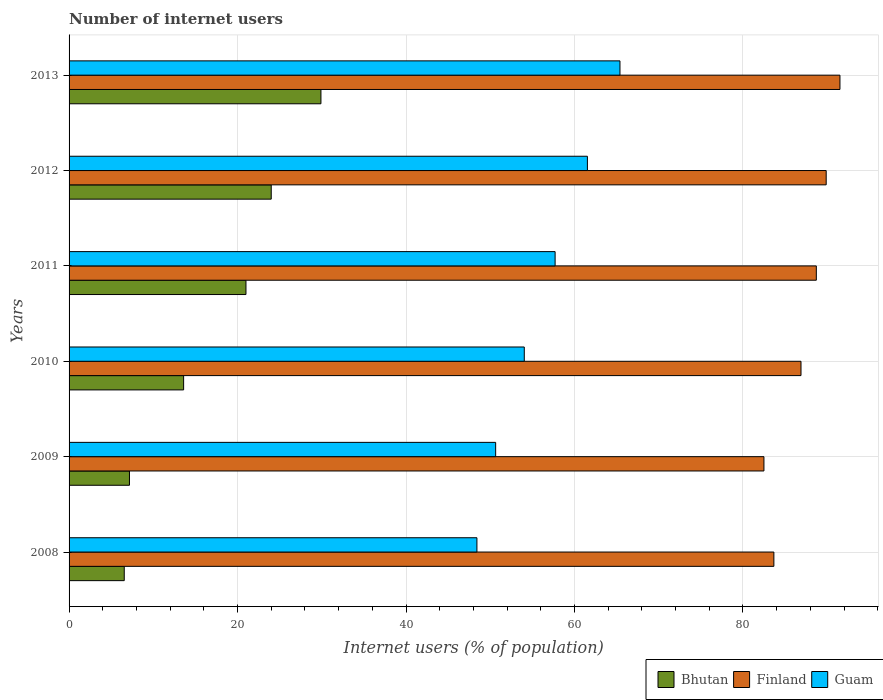How many different coloured bars are there?
Provide a short and direct response. 3. How many bars are there on the 2nd tick from the top?
Keep it short and to the point. 3. How many bars are there on the 3rd tick from the bottom?
Keep it short and to the point. 3. What is the label of the 6th group of bars from the top?
Keep it short and to the point. 2008. What is the number of internet users in Finland in 2008?
Give a very brief answer. 83.67. Across all years, what is the maximum number of internet users in Guam?
Your answer should be compact. 65.4. Across all years, what is the minimum number of internet users in Bhutan?
Provide a short and direct response. 6.55. In which year was the number of internet users in Finland maximum?
Keep it short and to the point. 2013. What is the total number of internet users in Finland in the graph?
Keep it short and to the point. 523.15. What is the difference between the number of internet users in Finland in 2011 and that in 2013?
Make the answer very short. -2.8. What is the difference between the number of internet users in Guam in 2010 and the number of internet users in Finland in 2009?
Give a very brief answer. -28.45. What is the average number of internet users in Bhutan per year?
Keep it short and to the point. 17.04. In the year 2013, what is the difference between the number of internet users in Finland and number of internet users in Bhutan?
Ensure brevity in your answer.  61.61. In how many years, is the number of internet users in Bhutan greater than 88 %?
Offer a very short reply. 0. What is the ratio of the number of internet users in Bhutan in 2008 to that in 2009?
Give a very brief answer. 0.91. Is the number of internet users in Finland in 2012 less than that in 2013?
Provide a succinct answer. Yes. What is the difference between the highest and the second highest number of internet users in Guam?
Make the answer very short. 3.87. What is the difference between the highest and the lowest number of internet users in Finland?
Your answer should be very brief. 9.02. What does the 1st bar from the top in 2013 represents?
Your answer should be very brief. Guam. What does the 1st bar from the bottom in 2008 represents?
Your response must be concise. Bhutan. Is it the case that in every year, the sum of the number of internet users in Bhutan and number of internet users in Guam is greater than the number of internet users in Finland?
Your answer should be very brief. No. How many bars are there?
Offer a terse response. 18. How many years are there in the graph?
Keep it short and to the point. 6. Are the values on the major ticks of X-axis written in scientific E-notation?
Keep it short and to the point. No. Does the graph contain any zero values?
Offer a very short reply. No. Does the graph contain grids?
Ensure brevity in your answer.  Yes. Where does the legend appear in the graph?
Your answer should be compact. Bottom right. How many legend labels are there?
Ensure brevity in your answer.  3. What is the title of the graph?
Ensure brevity in your answer.  Number of internet users. What is the label or title of the X-axis?
Ensure brevity in your answer.  Internet users (% of population). What is the Internet users (% of population) of Bhutan in 2008?
Make the answer very short. 6.55. What is the Internet users (% of population) in Finland in 2008?
Your answer should be compact. 83.67. What is the Internet users (% of population) of Guam in 2008?
Provide a short and direct response. 48.42. What is the Internet users (% of population) of Bhutan in 2009?
Give a very brief answer. 7.17. What is the Internet users (% of population) in Finland in 2009?
Offer a terse response. 82.49. What is the Internet users (% of population) of Guam in 2009?
Ensure brevity in your answer.  50.64. What is the Internet users (% of population) in Finland in 2010?
Your answer should be very brief. 86.89. What is the Internet users (% of population) in Guam in 2010?
Offer a terse response. 54.04. What is the Internet users (% of population) of Finland in 2011?
Offer a very short reply. 88.71. What is the Internet users (% of population) of Guam in 2011?
Offer a very short reply. 57.7. What is the Internet users (% of population) of Finland in 2012?
Make the answer very short. 89.88. What is the Internet users (% of population) of Guam in 2012?
Offer a very short reply. 61.53. What is the Internet users (% of population) of Bhutan in 2013?
Your answer should be very brief. 29.9. What is the Internet users (% of population) in Finland in 2013?
Make the answer very short. 91.51. What is the Internet users (% of population) of Guam in 2013?
Give a very brief answer. 65.4. Across all years, what is the maximum Internet users (% of population) of Bhutan?
Your response must be concise. 29.9. Across all years, what is the maximum Internet users (% of population) in Finland?
Give a very brief answer. 91.51. Across all years, what is the maximum Internet users (% of population) of Guam?
Offer a very short reply. 65.4. Across all years, what is the minimum Internet users (% of population) in Bhutan?
Offer a very short reply. 6.55. Across all years, what is the minimum Internet users (% of population) in Finland?
Offer a terse response. 82.49. Across all years, what is the minimum Internet users (% of population) of Guam?
Your answer should be very brief. 48.42. What is the total Internet users (% of population) in Bhutan in the graph?
Keep it short and to the point. 102.22. What is the total Internet users (% of population) of Finland in the graph?
Ensure brevity in your answer.  523.15. What is the total Internet users (% of population) in Guam in the graph?
Offer a terse response. 337.73. What is the difference between the Internet users (% of population) of Bhutan in 2008 and that in 2009?
Ensure brevity in your answer.  -0.62. What is the difference between the Internet users (% of population) in Finland in 2008 and that in 2009?
Offer a very short reply. 1.18. What is the difference between the Internet users (% of population) of Guam in 2008 and that in 2009?
Offer a very short reply. -2.22. What is the difference between the Internet users (% of population) in Bhutan in 2008 and that in 2010?
Make the answer very short. -7.05. What is the difference between the Internet users (% of population) in Finland in 2008 and that in 2010?
Ensure brevity in your answer.  -3.22. What is the difference between the Internet users (% of population) of Guam in 2008 and that in 2010?
Ensure brevity in your answer.  -5.62. What is the difference between the Internet users (% of population) of Bhutan in 2008 and that in 2011?
Offer a terse response. -14.45. What is the difference between the Internet users (% of population) of Finland in 2008 and that in 2011?
Make the answer very short. -5.04. What is the difference between the Internet users (% of population) in Guam in 2008 and that in 2011?
Offer a terse response. -9.28. What is the difference between the Internet users (% of population) in Bhutan in 2008 and that in 2012?
Give a very brief answer. -17.45. What is the difference between the Internet users (% of population) of Finland in 2008 and that in 2012?
Offer a very short reply. -6.21. What is the difference between the Internet users (% of population) of Guam in 2008 and that in 2012?
Ensure brevity in your answer.  -13.12. What is the difference between the Internet users (% of population) in Bhutan in 2008 and that in 2013?
Keep it short and to the point. -23.35. What is the difference between the Internet users (% of population) of Finland in 2008 and that in 2013?
Offer a very short reply. -7.84. What is the difference between the Internet users (% of population) in Guam in 2008 and that in 2013?
Your answer should be very brief. -16.98. What is the difference between the Internet users (% of population) in Bhutan in 2009 and that in 2010?
Provide a succinct answer. -6.43. What is the difference between the Internet users (% of population) in Finland in 2009 and that in 2010?
Your answer should be compact. -4.4. What is the difference between the Internet users (% of population) of Guam in 2009 and that in 2010?
Offer a very short reply. -3.4. What is the difference between the Internet users (% of population) of Bhutan in 2009 and that in 2011?
Offer a terse response. -13.83. What is the difference between the Internet users (% of population) of Finland in 2009 and that in 2011?
Make the answer very short. -6.22. What is the difference between the Internet users (% of population) of Guam in 2009 and that in 2011?
Provide a short and direct response. -7.06. What is the difference between the Internet users (% of population) in Bhutan in 2009 and that in 2012?
Make the answer very short. -16.83. What is the difference between the Internet users (% of population) of Finland in 2009 and that in 2012?
Provide a succinct answer. -7.39. What is the difference between the Internet users (% of population) in Guam in 2009 and that in 2012?
Your answer should be very brief. -10.89. What is the difference between the Internet users (% of population) of Bhutan in 2009 and that in 2013?
Offer a very short reply. -22.73. What is the difference between the Internet users (% of population) in Finland in 2009 and that in 2013?
Your answer should be compact. -9.02. What is the difference between the Internet users (% of population) in Guam in 2009 and that in 2013?
Provide a succinct answer. -14.76. What is the difference between the Internet users (% of population) in Finland in 2010 and that in 2011?
Provide a succinct answer. -1.82. What is the difference between the Internet users (% of population) of Guam in 2010 and that in 2011?
Keep it short and to the point. -3.66. What is the difference between the Internet users (% of population) of Finland in 2010 and that in 2012?
Make the answer very short. -2.99. What is the difference between the Internet users (% of population) of Guam in 2010 and that in 2012?
Give a very brief answer. -7.49. What is the difference between the Internet users (% of population) in Bhutan in 2010 and that in 2013?
Give a very brief answer. -16.3. What is the difference between the Internet users (% of population) in Finland in 2010 and that in 2013?
Make the answer very short. -4.62. What is the difference between the Internet users (% of population) of Guam in 2010 and that in 2013?
Make the answer very short. -11.36. What is the difference between the Internet users (% of population) of Bhutan in 2011 and that in 2012?
Give a very brief answer. -3. What is the difference between the Internet users (% of population) in Finland in 2011 and that in 2012?
Ensure brevity in your answer.  -1.17. What is the difference between the Internet users (% of population) in Guam in 2011 and that in 2012?
Make the answer very short. -3.83. What is the difference between the Internet users (% of population) of Bhutan in 2011 and that in 2013?
Provide a short and direct response. -8.9. What is the difference between the Internet users (% of population) of Finland in 2011 and that in 2013?
Offer a very short reply. -2.8. What is the difference between the Internet users (% of population) in Guam in 2011 and that in 2013?
Your answer should be compact. -7.7. What is the difference between the Internet users (% of population) of Bhutan in 2012 and that in 2013?
Keep it short and to the point. -5.9. What is the difference between the Internet users (% of population) in Finland in 2012 and that in 2013?
Provide a short and direct response. -1.63. What is the difference between the Internet users (% of population) in Guam in 2012 and that in 2013?
Provide a succinct answer. -3.87. What is the difference between the Internet users (% of population) of Bhutan in 2008 and the Internet users (% of population) of Finland in 2009?
Ensure brevity in your answer.  -75.94. What is the difference between the Internet users (% of population) of Bhutan in 2008 and the Internet users (% of population) of Guam in 2009?
Your answer should be compact. -44.09. What is the difference between the Internet users (% of population) in Finland in 2008 and the Internet users (% of population) in Guam in 2009?
Keep it short and to the point. 33.03. What is the difference between the Internet users (% of population) in Bhutan in 2008 and the Internet users (% of population) in Finland in 2010?
Your answer should be compact. -80.34. What is the difference between the Internet users (% of population) in Bhutan in 2008 and the Internet users (% of population) in Guam in 2010?
Offer a terse response. -47.49. What is the difference between the Internet users (% of population) of Finland in 2008 and the Internet users (% of population) of Guam in 2010?
Make the answer very short. 29.63. What is the difference between the Internet users (% of population) of Bhutan in 2008 and the Internet users (% of population) of Finland in 2011?
Offer a terse response. -82.16. What is the difference between the Internet users (% of population) in Bhutan in 2008 and the Internet users (% of population) in Guam in 2011?
Your answer should be compact. -51.15. What is the difference between the Internet users (% of population) of Finland in 2008 and the Internet users (% of population) of Guam in 2011?
Make the answer very short. 25.97. What is the difference between the Internet users (% of population) in Bhutan in 2008 and the Internet users (% of population) in Finland in 2012?
Give a very brief answer. -83.33. What is the difference between the Internet users (% of population) in Bhutan in 2008 and the Internet users (% of population) in Guam in 2012?
Your response must be concise. -54.98. What is the difference between the Internet users (% of population) of Finland in 2008 and the Internet users (% of population) of Guam in 2012?
Your response must be concise. 22.14. What is the difference between the Internet users (% of population) in Bhutan in 2008 and the Internet users (% of population) in Finland in 2013?
Your answer should be compact. -84.96. What is the difference between the Internet users (% of population) in Bhutan in 2008 and the Internet users (% of population) in Guam in 2013?
Offer a terse response. -58.85. What is the difference between the Internet users (% of population) of Finland in 2008 and the Internet users (% of population) of Guam in 2013?
Provide a succinct answer. 18.27. What is the difference between the Internet users (% of population) of Bhutan in 2009 and the Internet users (% of population) of Finland in 2010?
Your answer should be very brief. -79.72. What is the difference between the Internet users (% of population) in Bhutan in 2009 and the Internet users (% of population) in Guam in 2010?
Make the answer very short. -46.87. What is the difference between the Internet users (% of population) of Finland in 2009 and the Internet users (% of population) of Guam in 2010?
Make the answer very short. 28.45. What is the difference between the Internet users (% of population) of Bhutan in 2009 and the Internet users (% of population) of Finland in 2011?
Give a very brief answer. -81.54. What is the difference between the Internet users (% of population) in Bhutan in 2009 and the Internet users (% of population) in Guam in 2011?
Keep it short and to the point. -50.53. What is the difference between the Internet users (% of population) in Finland in 2009 and the Internet users (% of population) in Guam in 2011?
Make the answer very short. 24.79. What is the difference between the Internet users (% of population) in Bhutan in 2009 and the Internet users (% of population) in Finland in 2012?
Provide a succinct answer. -82.71. What is the difference between the Internet users (% of population) in Bhutan in 2009 and the Internet users (% of population) in Guam in 2012?
Make the answer very short. -54.36. What is the difference between the Internet users (% of population) in Finland in 2009 and the Internet users (% of population) in Guam in 2012?
Offer a terse response. 20.96. What is the difference between the Internet users (% of population) of Bhutan in 2009 and the Internet users (% of population) of Finland in 2013?
Your answer should be very brief. -84.34. What is the difference between the Internet users (% of population) in Bhutan in 2009 and the Internet users (% of population) in Guam in 2013?
Keep it short and to the point. -58.23. What is the difference between the Internet users (% of population) in Finland in 2009 and the Internet users (% of population) in Guam in 2013?
Provide a short and direct response. 17.09. What is the difference between the Internet users (% of population) of Bhutan in 2010 and the Internet users (% of population) of Finland in 2011?
Provide a succinct answer. -75.11. What is the difference between the Internet users (% of population) of Bhutan in 2010 and the Internet users (% of population) of Guam in 2011?
Make the answer very short. -44.1. What is the difference between the Internet users (% of population) in Finland in 2010 and the Internet users (% of population) in Guam in 2011?
Your answer should be compact. 29.19. What is the difference between the Internet users (% of population) in Bhutan in 2010 and the Internet users (% of population) in Finland in 2012?
Provide a succinct answer. -76.28. What is the difference between the Internet users (% of population) in Bhutan in 2010 and the Internet users (% of population) in Guam in 2012?
Offer a very short reply. -47.93. What is the difference between the Internet users (% of population) in Finland in 2010 and the Internet users (% of population) in Guam in 2012?
Make the answer very short. 25.36. What is the difference between the Internet users (% of population) in Bhutan in 2010 and the Internet users (% of population) in Finland in 2013?
Keep it short and to the point. -77.91. What is the difference between the Internet users (% of population) of Bhutan in 2010 and the Internet users (% of population) of Guam in 2013?
Make the answer very short. -51.8. What is the difference between the Internet users (% of population) of Finland in 2010 and the Internet users (% of population) of Guam in 2013?
Offer a very short reply. 21.49. What is the difference between the Internet users (% of population) in Bhutan in 2011 and the Internet users (% of population) in Finland in 2012?
Your answer should be very brief. -68.88. What is the difference between the Internet users (% of population) of Bhutan in 2011 and the Internet users (% of population) of Guam in 2012?
Make the answer very short. -40.53. What is the difference between the Internet users (% of population) of Finland in 2011 and the Internet users (% of population) of Guam in 2012?
Offer a very short reply. 27.18. What is the difference between the Internet users (% of population) in Bhutan in 2011 and the Internet users (% of population) in Finland in 2013?
Make the answer very short. -70.51. What is the difference between the Internet users (% of population) in Bhutan in 2011 and the Internet users (% of population) in Guam in 2013?
Make the answer very short. -44.4. What is the difference between the Internet users (% of population) of Finland in 2011 and the Internet users (% of population) of Guam in 2013?
Your response must be concise. 23.31. What is the difference between the Internet users (% of population) of Bhutan in 2012 and the Internet users (% of population) of Finland in 2013?
Ensure brevity in your answer.  -67.51. What is the difference between the Internet users (% of population) in Bhutan in 2012 and the Internet users (% of population) in Guam in 2013?
Provide a succinct answer. -41.4. What is the difference between the Internet users (% of population) in Finland in 2012 and the Internet users (% of population) in Guam in 2013?
Make the answer very short. 24.48. What is the average Internet users (% of population) of Bhutan per year?
Make the answer very short. 17.04. What is the average Internet users (% of population) of Finland per year?
Your response must be concise. 87.19. What is the average Internet users (% of population) of Guam per year?
Give a very brief answer. 56.29. In the year 2008, what is the difference between the Internet users (% of population) of Bhutan and Internet users (% of population) of Finland?
Offer a terse response. -77.12. In the year 2008, what is the difference between the Internet users (% of population) in Bhutan and Internet users (% of population) in Guam?
Your answer should be compact. -41.87. In the year 2008, what is the difference between the Internet users (% of population) of Finland and Internet users (% of population) of Guam?
Provide a short and direct response. 35.25. In the year 2009, what is the difference between the Internet users (% of population) of Bhutan and Internet users (% of population) of Finland?
Your answer should be compact. -75.32. In the year 2009, what is the difference between the Internet users (% of population) of Bhutan and Internet users (% of population) of Guam?
Provide a succinct answer. -43.47. In the year 2009, what is the difference between the Internet users (% of population) of Finland and Internet users (% of population) of Guam?
Your answer should be very brief. 31.85. In the year 2010, what is the difference between the Internet users (% of population) of Bhutan and Internet users (% of population) of Finland?
Provide a short and direct response. -73.29. In the year 2010, what is the difference between the Internet users (% of population) in Bhutan and Internet users (% of population) in Guam?
Provide a succinct answer. -40.44. In the year 2010, what is the difference between the Internet users (% of population) of Finland and Internet users (% of population) of Guam?
Give a very brief answer. 32.85. In the year 2011, what is the difference between the Internet users (% of population) of Bhutan and Internet users (% of population) of Finland?
Keep it short and to the point. -67.71. In the year 2011, what is the difference between the Internet users (% of population) in Bhutan and Internet users (% of population) in Guam?
Make the answer very short. -36.7. In the year 2011, what is the difference between the Internet users (% of population) of Finland and Internet users (% of population) of Guam?
Your answer should be very brief. 31.01. In the year 2012, what is the difference between the Internet users (% of population) in Bhutan and Internet users (% of population) in Finland?
Provide a short and direct response. -65.88. In the year 2012, what is the difference between the Internet users (% of population) of Bhutan and Internet users (% of population) of Guam?
Your answer should be compact. -37.53. In the year 2012, what is the difference between the Internet users (% of population) of Finland and Internet users (% of population) of Guam?
Provide a succinct answer. 28.35. In the year 2013, what is the difference between the Internet users (% of population) of Bhutan and Internet users (% of population) of Finland?
Provide a succinct answer. -61.61. In the year 2013, what is the difference between the Internet users (% of population) in Bhutan and Internet users (% of population) in Guam?
Ensure brevity in your answer.  -35.5. In the year 2013, what is the difference between the Internet users (% of population) in Finland and Internet users (% of population) in Guam?
Offer a terse response. 26.11. What is the ratio of the Internet users (% of population) in Bhutan in 2008 to that in 2009?
Provide a short and direct response. 0.91. What is the ratio of the Internet users (% of population) in Finland in 2008 to that in 2009?
Provide a short and direct response. 1.01. What is the ratio of the Internet users (% of population) in Guam in 2008 to that in 2009?
Offer a terse response. 0.96. What is the ratio of the Internet users (% of population) of Bhutan in 2008 to that in 2010?
Give a very brief answer. 0.48. What is the ratio of the Internet users (% of population) in Finland in 2008 to that in 2010?
Ensure brevity in your answer.  0.96. What is the ratio of the Internet users (% of population) in Guam in 2008 to that in 2010?
Keep it short and to the point. 0.9. What is the ratio of the Internet users (% of population) of Bhutan in 2008 to that in 2011?
Offer a very short reply. 0.31. What is the ratio of the Internet users (% of population) in Finland in 2008 to that in 2011?
Offer a very short reply. 0.94. What is the ratio of the Internet users (% of population) of Guam in 2008 to that in 2011?
Make the answer very short. 0.84. What is the ratio of the Internet users (% of population) in Bhutan in 2008 to that in 2012?
Offer a terse response. 0.27. What is the ratio of the Internet users (% of population) in Finland in 2008 to that in 2012?
Your answer should be compact. 0.93. What is the ratio of the Internet users (% of population) of Guam in 2008 to that in 2012?
Make the answer very short. 0.79. What is the ratio of the Internet users (% of population) of Bhutan in 2008 to that in 2013?
Offer a very short reply. 0.22. What is the ratio of the Internet users (% of population) of Finland in 2008 to that in 2013?
Offer a terse response. 0.91. What is the ratio of the Internet users (% of population) in Guam in 2008 to that in 2013?
Your response must be concise. 0.74. What is the ratio of the Internet users (% of population) in Bhutan in 2009 to that in 2010?
Offer a terse response. 0.53. What is the ratio of the Internet users (% of population) of Finland in 2009 to that in 2010?
Your answer should be very brief. 0.95. What is the ratio of the Internet users (% of population) of Guam in 2009 to that in 2010?
Offer a terse response. 0.94. What is the ratio of the Internet users (% of population) of Bhutan in 2009 to that in 2011?
Your response must be concise. 0.34. What is the ratio of the Internet users (% of population) in Finland in 2009 to that in 2011?
Offer a very short reply. 0.93. What is the ratio of the Internet users (% of population) in Guam in 2009 to that in 2011?
Give a very brief answer. 0.88. What is the ratio of the Internet users (% of population) in Bhutan in 2009 to that in 2012?
Offer a very short reply. 0.3. What is the ratio of the Internet users (% of population) of Finland in 2009 to that in 2012?
Your answer should be compact. 0.92. What is the ratio of the Internet users (% of population) in Guam in 2009 to that in 2012?
Provide a short and direct response. 0.82. What is the ratio of the Internet users (% of population) in Bhutan in 2009 to that in 2013?
Keep it short and to the point. 0.24. What is the ratio of the Internet users (% of population) in Finland in 2009 to that in 2013?
Offer a very short reply. 0.9. What is the ratio of the Internet users (% of population) of Guam in 2009 to that in 2013?
Give a very brief answer. 0.77. What is the ratio of the Internet users (% of population) of Bhutan in 2010 to that in 2011?
Your answer should be very brief. 0.65. What is the ratio of the Internet users (% of population) in Finland in 2010 to that in 2011?
Make the answer very short. 0.98. What is the ratio of the Internet users (% of population) in Guam in 2010 to that in 2011?
Your response must be concise. 0.94. What is the ratio of the Internet users (% of population) of Bhutan in 2010 to that in 2012?
Your answer should be compact. 0.57. What is the ratio of the Internet users (% of population) in Finland in 2010 to that in 2012?
Your response must be concise. 0.97. What is the ratio of the Internet users (% of population) in Guam in 2010 to that in 2012?
Provide a succinct answer. 0.88. What is the ratio of the Internet users (% of population) of Bhutan in 2010 to that in 2013?
Provide a short and direct response. 0.45. What is the ratio of the Internet users (% of population) in Finland in 2010 to that in 2013?
Your response must be concise. 0.95. What is the ratio of the Internet users (% of population) of Guam in 2010 to that in 2013?
Provide a short and direct response. 0.83. What is the ratio of the Internet users (% of population) in Bhutan in 2011 to that in 2012?
Your answer should be compact. 0.88. What is the ratio of the Internet users (% of population) in Finland in 2011 to that in 2012?
Offer a terse response. 0.99. What is the ratio of the Internet users (% of population) of Guam in 2011 to that in 2012?
Keep it short and to the point. 0.94. What is the ratio of the Internet users (% of population) of Bhutan in 2011 to that in 2013?
Ensure brevity in your answer.  0.7. What is the ratio of the Internet users (% of population) of Finland in 2011 to that in 2013?
Provide a short and direct response. 0.97. What is the ratio of the Internet users (% of population) in Guam in 2011 to that in 2013?
Your response must be concise. 0.88. What is the ratio of the Internet users (% of population) of Bhutan in 2012 to that in 2013?
Provide a short and direct response. 0.8. What is the ratio of the Internet users (% of population) in Finland in 2012 to that in 2013?
Ensure brevity in your answer.  0.98. What is the ratio of the Internet users (% of population) of Guam in 2012 to that in 2013?
Offer a terse response. 0.94. What is the difference between the highest and the second highest Internet users (% of population) in Finland?
Give a very brief answer. 1.63. What is the difference between the highest and the second highest Internet users (% of population) in Guam?
Give a very brief answer. 3.87. What is the difference between the highest and the lowest Internet users (% of population) in Bhutan?
Your answer should be compact. 23.35. What is the difference between the highest and the lowest Internet users (% of population) of Finland?
Your answer should be compact. 9.02. What is the difference between the highest and the lowest Internet users (% of population) in Guam?
Your answer should be very brief. 16.98. 